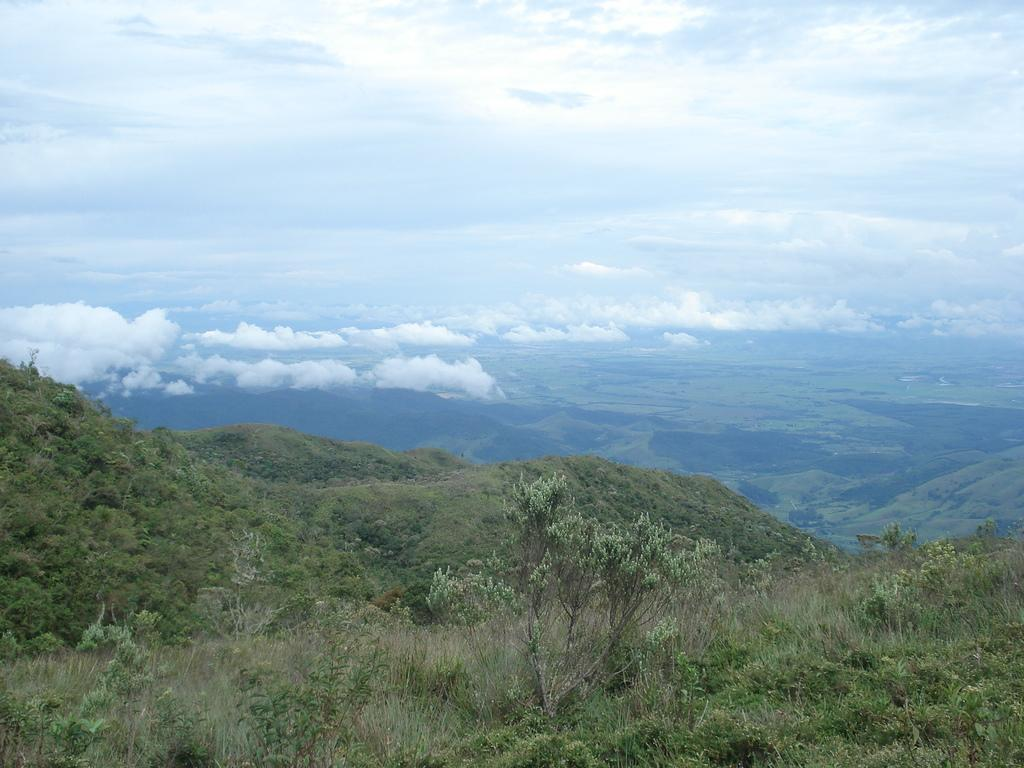Where was the image taken? The image was clicked on the hills. What can be seen on the hills in the image? There are plants and grass on the hills. What is visible in the background of the image? There are hills visible in the background of the image. What is visible at the top of the image? The sky is visible at the top of the image. What is the condition of the sky in the image? The sky is cloudy in the image. What type of spark can be seen coming from the throne in the image? There is no throne present in the image, so there cannot be any spark coming from it. How many balls are visible on the hills in the image? There are no balls visible on the hills in the image. 